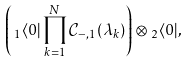Convert formula to latex. <formula><loc_0><loc_0><loc_500><loc_500>\left ( \, _ { 1 } \langle 0 | \prod _ { k = 1 } ^ { N } \mathcal { C } _ { - , 1 } ( \lambda _ { k } ) \right ) \otimes \, _ { 2 } \langle 0 | ,</formula> 